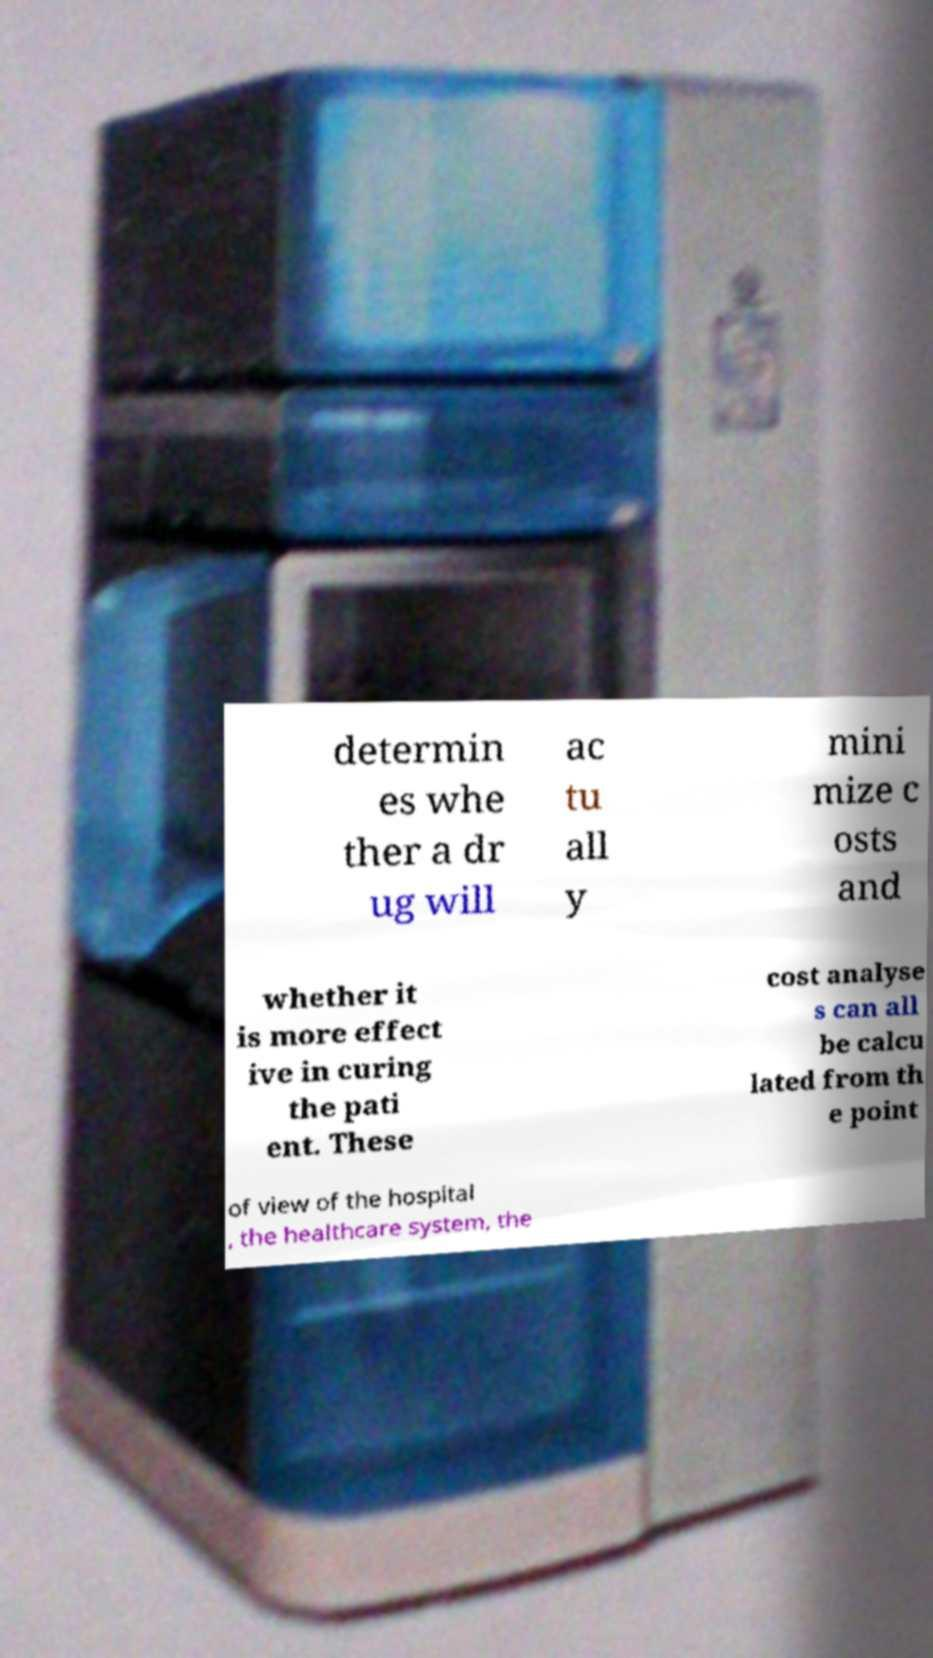Could you assist in decoding the text presented in this image and type it out clearly? determin es whe ther a dr ug will ac tu all y mini mize c osts and whether it is more effect ive in curing the pati ent. These cost analyse s can all be calcu lated from th e point of view of the hospital , the healthcare system, the 